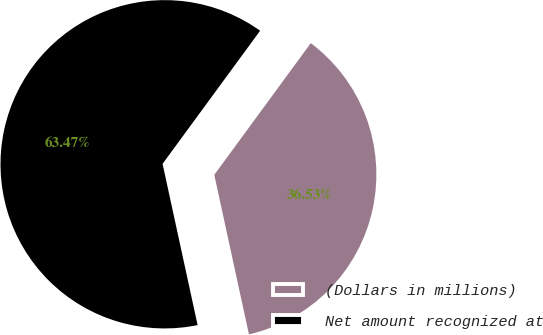Convert chart to OTSL. <chart><loc_0><loc_0><loc_500><loc_500><pie_chart><fcel>(Dollars in millions)<fcel>Net amount recognized at<nl><fcel>36.53%<fcel>63.47%<nl></chart> 